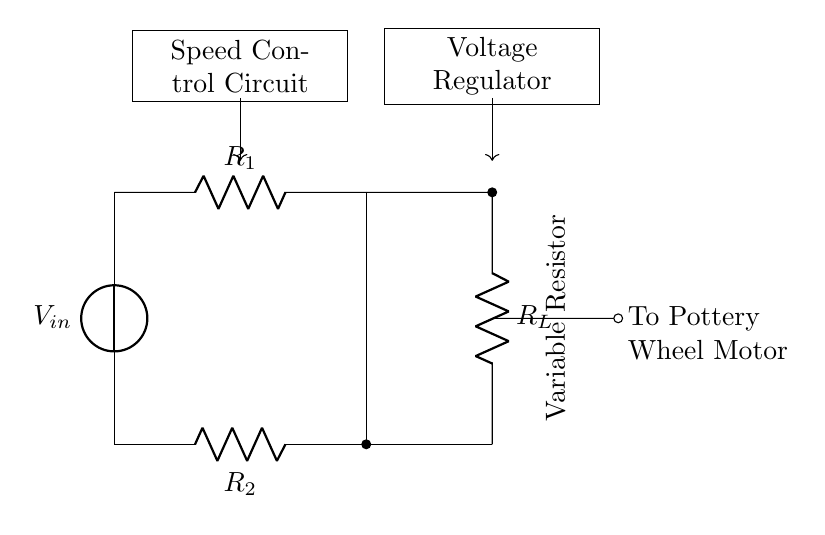What are the resistors in this circuit? The circuit shows two resistors labeled R1 and R2, which are connected in a current divider configuration for voltage regulation.
Answer: R1, R2 What is the purpose of the variable resistor? The variable resistor, also known as a rheostat, allows adjustment of the resistance value, which consequently changes the motor speed by varying the voltage across the motor.
Answer: Speed control How does the current divide between R1 and R2? In a current divider circuit, the current splits based on the resistance values of R1 and R2, where a higher resistance creates less current and a lower resistance allows more current to flow through.
Answer: Based on resistance What is the function of R_L in the circuit? R_L acts as the load resistor, which represents the pottery wheel motor, and it receives the divided voltage from the current divider to operate at the desired speed.
Answer: Load resistor What happens to the voltage across R_L when R1 is increased? Increasing R1 raises the total resistance, which decreases the total current flowing through the circuit, thereby reducing the voltage across R_L.
Answer: Voltage decreases What is the arrangement of the circuit components? The circuit components are arranged in a parallel configuration with two resistors, R1 and R2, while R_L connects to the output of the divider for the wheel motor.
Answer: Parallel arrangement What indication is provided for the output to the pottery wheel motor? The circuit diagram includes a label indicating a connection ("To Pottery Wheel Motor") from the load resistor R_L, which signifies the output voltage supplying the motor.
Answer: Output to motor 